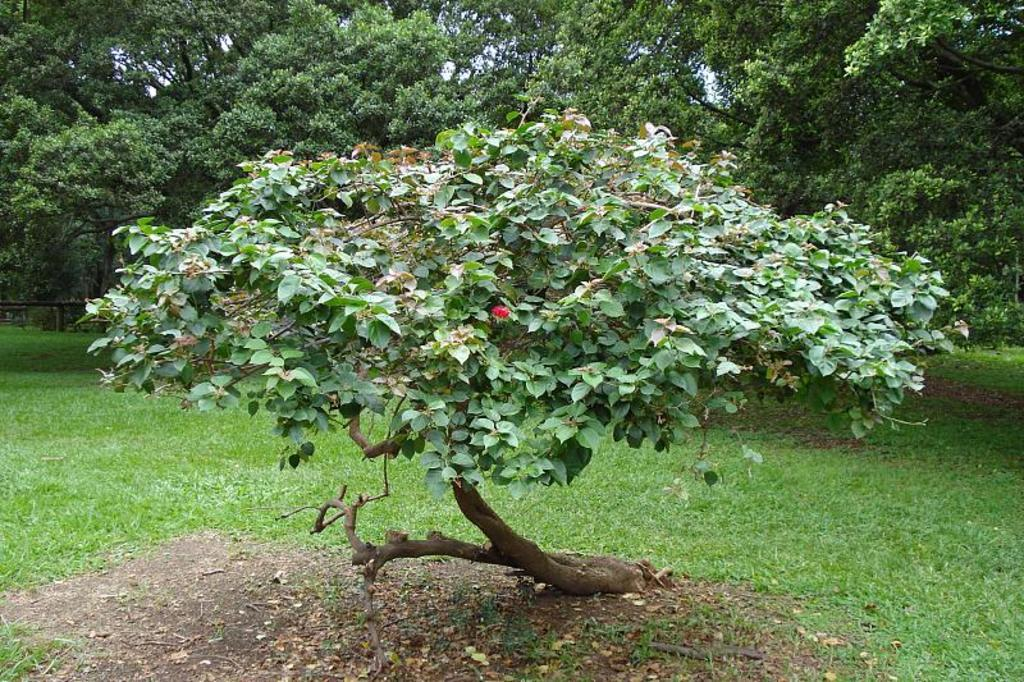What type of flower can be seen on a tree in the image? There is a red flower on a tree in the image. What can be found on the ground in the image? Grass is present on the ground in the image. What is visible among the trees in the background? There are trees in the background of the image. What else can be seen on the ground in the image? Dry leaves are visible in the image. What verse is being recited by the bee in the image? There is no bee present in the image, so there is no verse being recited. 